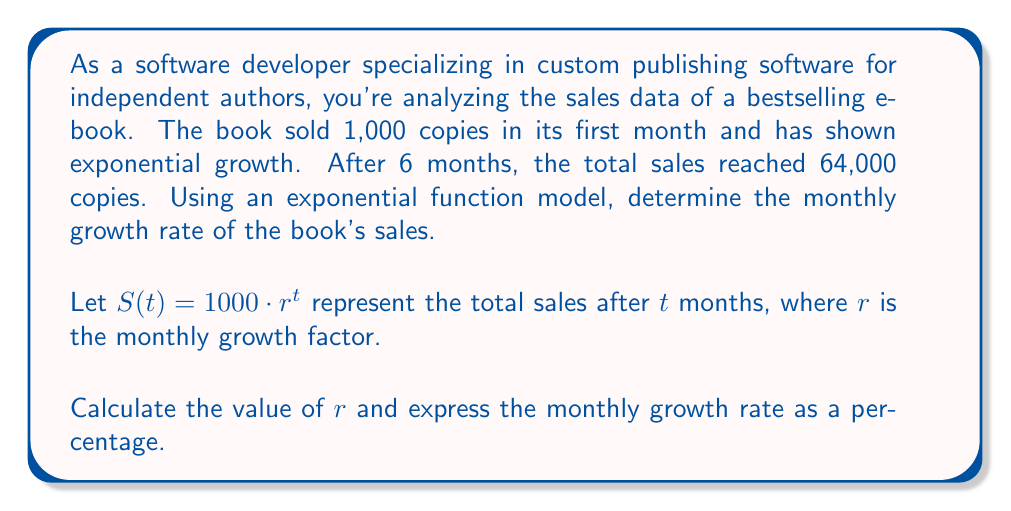Help me with this question. To solve this problem, we'll use the exponential growth function and the given information to determine the growth factor $r$. Then, we'll convert it to a percentage growth rate.

1) The exponential function model is:
   $S(t) = 1000 \cdot r^t$

2) We know that after 6 months $(t=6)$, the total sales were 64,000. Let's plug this into our equation:
   $64000 = 1000 \cdot r^6$

3) Divide both sides by 1000:
   $64 = r^6$

4) Take the 6th root of both sides:
   $\sqrt[6]{64} = r$

5) Simplify:
   $r = 2$

6) The growth factor is 2, meaning the sales double each month. To convert this to a percentage growth rate:
   Growth rate = (New value - Original value) / Original value * 100%
                = (2 - 1) / 1 * 100%
                = 1 * 100%
                = 100%

Therefore, the monthly growth rate is 100%.
Answer: The monthly growth rate of the book's sales is 100%. 